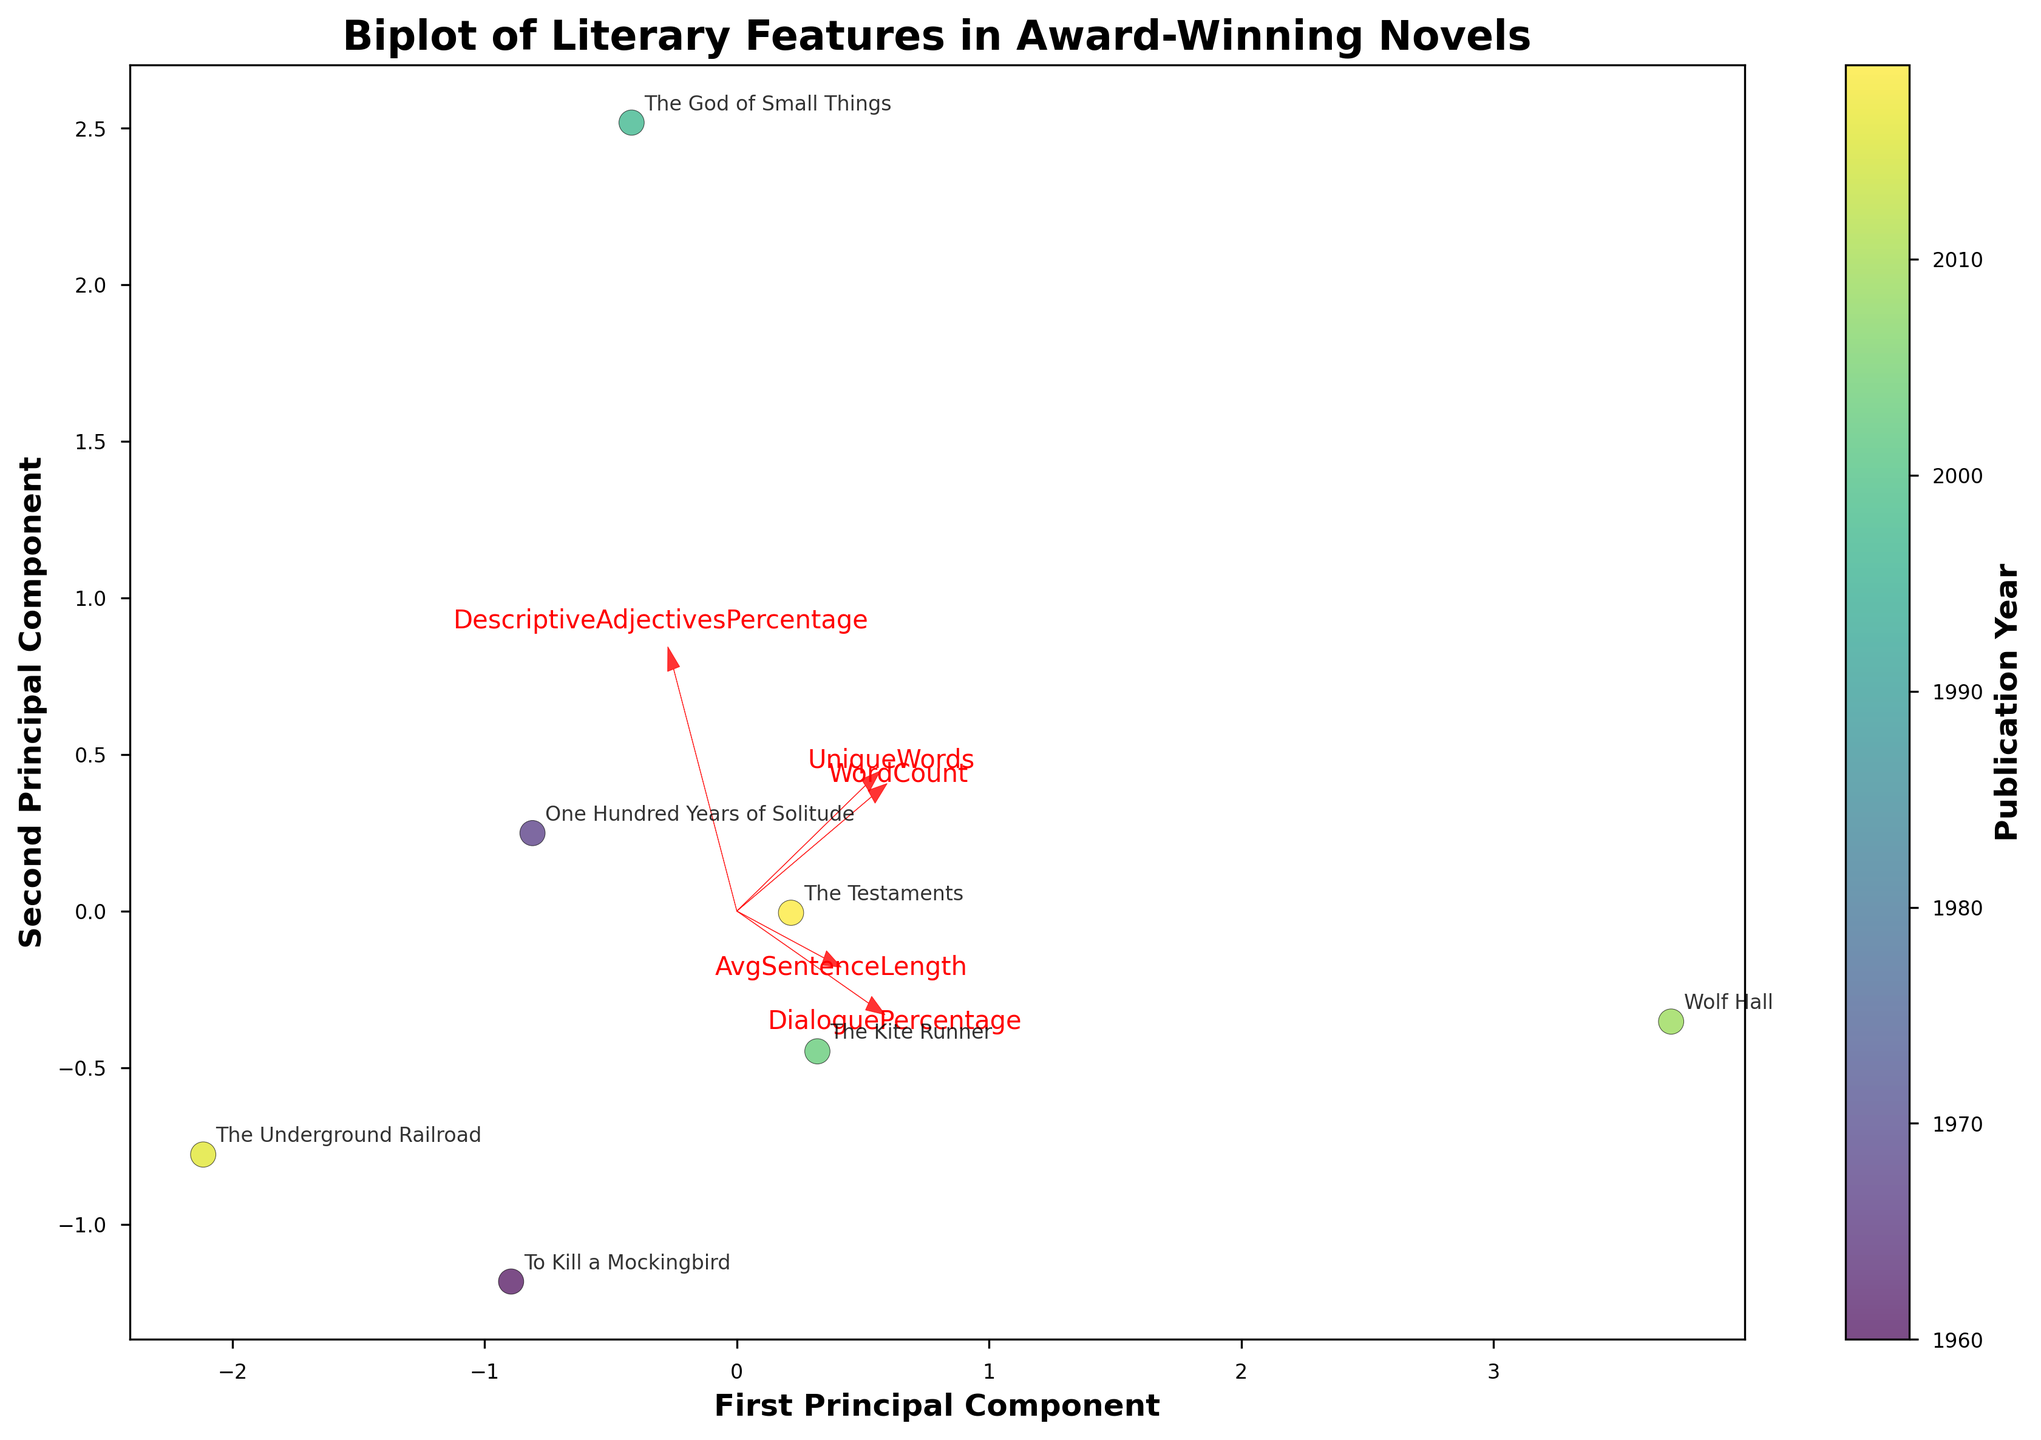What is the title of the biplot? The title of the biplot is displayed at the top of the figure. It specifically names the depiction regarding literary features in award-winning novels.
Answer: Biplot of Literary Features in Award-Winning Novels Which axis represents the first principal component? The biplot's axes are labeled to indicate which principal components they represent. The x-axis is labeled "First Principal Component".
Answer: x-axis How many data points are plotted in the biplot? Each data point corresponds to a novel in the dataset. By counting the number of distinct points or annotated titles, we can determine the total number.
Answer: 7 What feature had the highest loading on the second principal component? In a biplot, feature vectors show the direction and magnitude of each feature in principal component space. By looking at the vector with the longest projection on the y-axis (second principal component), we find the highest loading feature.
Answer: DescriptiveAdjectivesPercentage Which novel has the highest DialoguePercentage and where is it positioned relative to the principal components? We need to identify the novel with the highest DialoguePercentage from the given data and locate its position on the biplot. The Kite Runner has the highest DialoguePercentage (25.3%). On the biplot, it is positioned according to the PCA transformation and appears in the particular quadrant or section.
Answer: The Kite Runner, upper region Do more recent novels tend to cluster together? We observe the color gradient representing the publication year and look for clustering of similarly colored points in the biplot. If recent novels (darker colors) are close together, we answer affirmatively.
Answer: Yes Is there a clear separation between the novels of different decades? By examining the color distribution and spatial separation of data points on the biplot, we can observe whether distinct clusters form according to publication decade.
Answer: Some separation Which feature has the smallest impact on the first principal component? The arrows represent the contribution of each feature. We need to find the arrow that is the shortest along the x-axis (first principal component) to determine the feature with the smallest impact.
Answer: DescriptiveAdjectivesPercentage How does "One Hundred Years of Solitude" compare to "The God of Small Things" in terms of the first and second principal components? We locate the positions of both novels on the biplot and compare their coordinates on the x (first principal component) and y (second principal component) axes directly.
Answer: One Hundred Years of Solitude has higher values on both components What relationship exists between unique words and principal component projections? By examining the direction and magnitude of the UniqueWords vector and its alignment with principal components, we can infer how unique words influence the projections. The UniqueWords vector's direction shows it aligns more with the first principal component, indicating a stronger correlation with that axis.
Answer: Correlated with the first principal component 